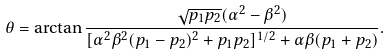<formula> <loc_0><loc_0><loc_500><loc_500>\theta = \arctan \frac { \sqrt { p _ { 1 } p _ { 2 } } ( \alpha ^ { 2 } - \beta ^ { 2 } ) } { [ \alpha ^ { 2 } \beta ^ { 2 } ( p _ { 1 } - p _ { 2 } ) ^ { 2 } + p _ { 1 } p _ { 2 } ] ^ { 1 / 2 } + \alpha \beta ( p _ { 1 } + p _ { 2 } ) } .</formula> 